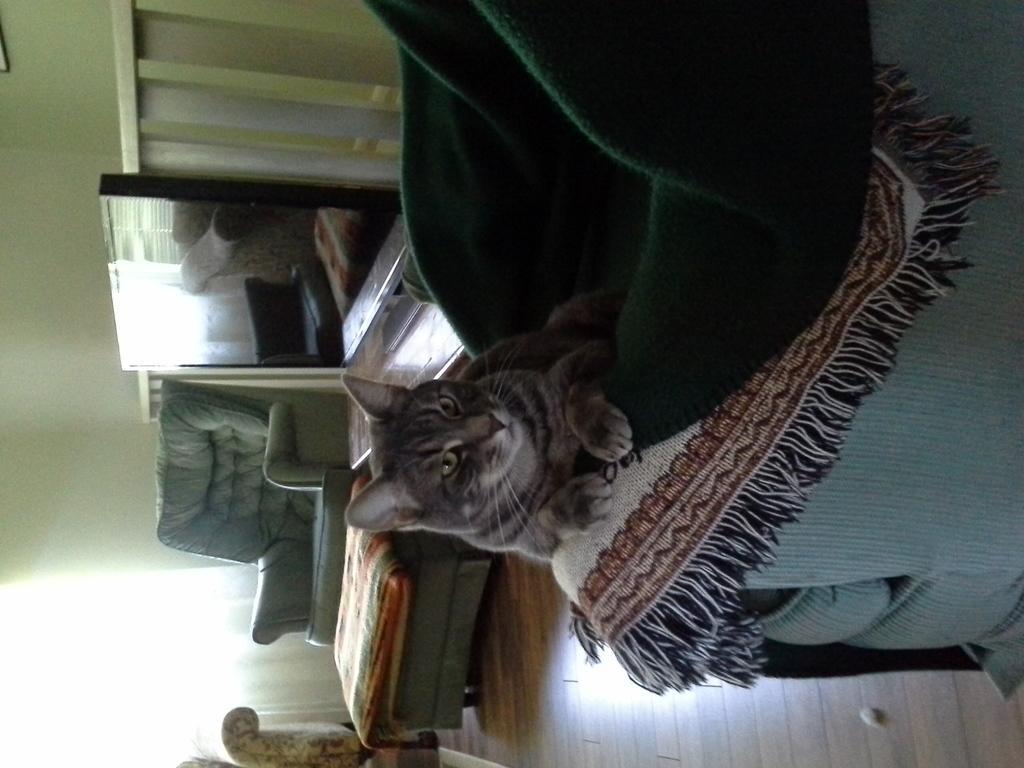Please provide a concise description of this image. In the image I can see a cat on the bed and to the side there is a screen, sofas and table. 